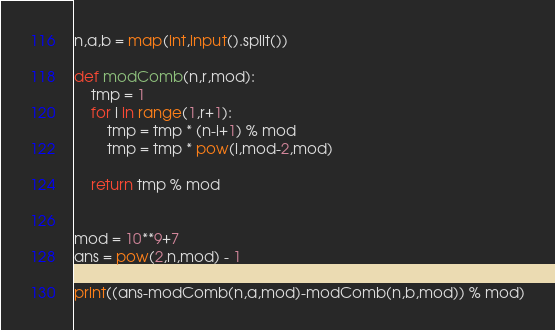Convert code to text. <code><loc_0><loc_0><loc_500><loc_500><_Python_>n,a,b = map(int,input().split())

def modComb(n,r,mod):
    tmp = 1
    for i in range(1,r+1):
        tmp = tmp * (n-i+1) % mod
        tmp = tmp * pow(i,mod-2,mod)
    
    return tmp % mod


mod = 10**9+7
ans = pow(2,n,mod) - 1

print((ans-modComb(n,a,mod)-modComb(n,b,mod)) % mod)

</code> 